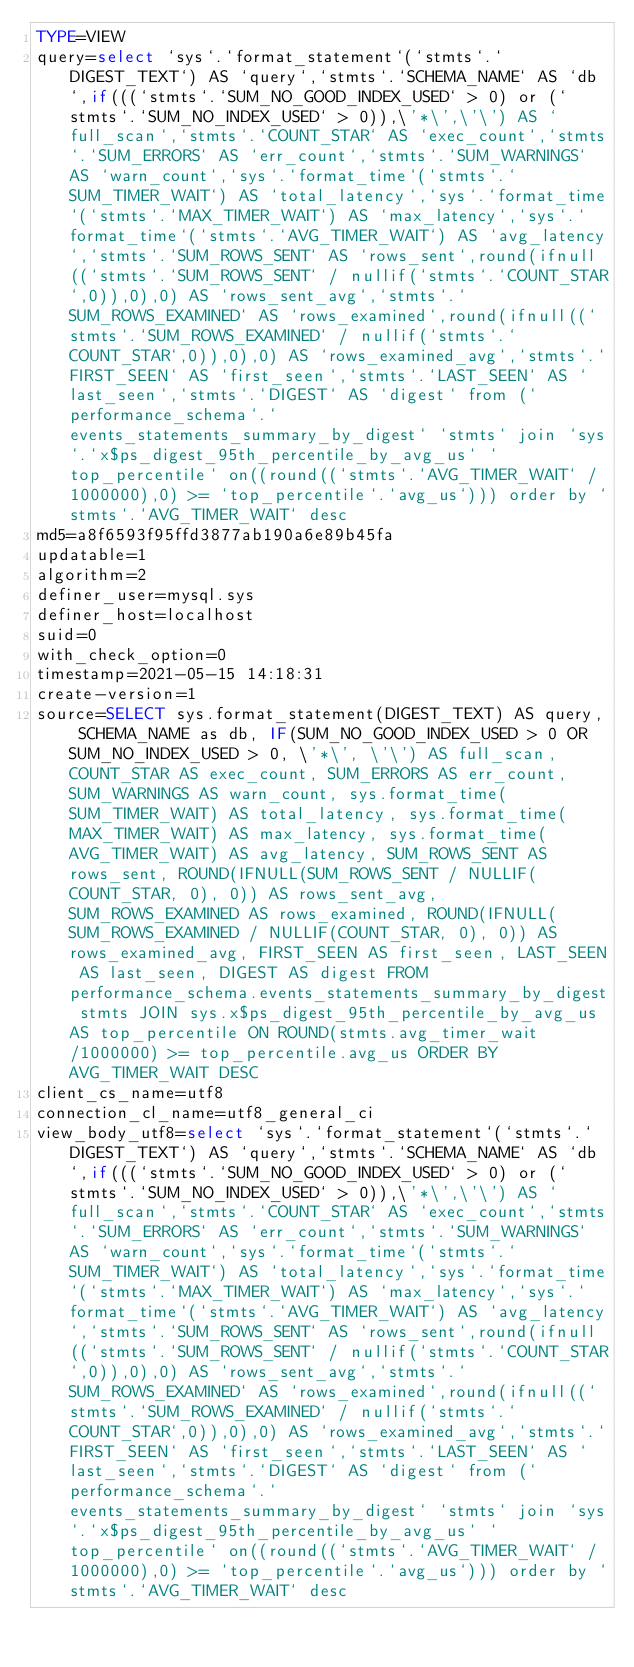<code> <loc_0><loc_0><loc_500><loc_500><_VisualBasic_>TYPE=VIEW
query=select `sys`.`format_statement`(`stmts`.`DIGEST_TEXT`) AS `query`,`stmts`.`SCHEMA_NAME` AS `db`,if(((`stmts`.`SUM_NO_GOOD_INDEX_USED` > 0) or (`stmts`.`SUM_NO_INDEX_USED` > 0)),\'*\',\'\') AS `full_scan`,`stmts`.`COUNT_STAR` AS `exec_count`,`stmts`.`SUM_ERRORS` AS `err_count`,`stmts`.`SUM_WARNINGS` AS `warn_count`,`sys`.`format_time`(`stmts`.`SUM_TIMER_WAIT`) AS `total_latency`,`sys`.`format_time`(`stmts`.`MAX_TIMER_WAIT`) AS `max_latency`,`sys`.`format_time`(`stmts`.`AVG_TIMER_WAIT`) AS `avg_latency`,`stmts`.`SUM_ROWS_SENT` AS `rows_sent`,round(ifnull((`stmts`.`SUM_ROWS_SENT` / nullif(`stmts`.`COUNT_STAR`,0)),0),0) AS `rows_sent_avg`,`stmts`.`SUM_ROWS_EXAMINED` AS `rows_examined`,round(ifnull((`stmts`.`SUM_ROWS_EXAMINED` / nullif(`stmts`.`COUNT_STAR`,0)),0),0) AS `rows_examined_avg`,`stmts`.`FIRST_SEEN` AS `first_seen`,`stmts`.`LAST_SEEN` AS `last_seen`,`stmts`.`DIGEST` AS `digest` from (`performance_schema`.`events_statements_summary_by_digest` `stmts` join `sys`.`x$ps_digest_95th_percentile_by_avg_us` `top_percentile` on((round((`stmts`.`AVG_TIMER_WAIT` / 1000000),0) >= `top_percentile`.`avg_us`))) order by `stmts`.`AVG_TIMER_WAIT` desc
md5=a8f6593f95ffd3877ab190a6e89b45fa
updatable=1
algorithm=2
definer_user=mysql.sys
definer_host=localhost
suid=0
with_check_option=0
timestamp=2021-05-15 14:18:31
create-version=1
source=SELECT sys.format_statement(DIGEST_TEXT) AS query, SCHEMA_NAME as db, IF(SUM_NO_GOOD_INDEX_USED > 0 OR SUM_NO_INDEX_USED > 0, \'*\', \'\') AS full_scan, COUNT_STAR AS exec_count, SUM_ERRORS AS err_count, SUM_WARNINGS AS warn_count, sys.format_time(SUM_TIMER_WAIT) AS total_latency, sys.format_time(MAX_TIMER_WAIT) AS max_latency, sys.format_time(AVG_TIMER_WAIT) AS avg_latency, SUM_ROWS_SENT AS rows_sent, ROUND(IFNULL(SUM_ROWS_SENT / NULLIF(COUNT_STAR, 0), 0)) AS rows_sent_avg, SUM_ROWS_EXAMINED AS rows_examined, ROUND(IFNULL(SUM_ROWS_EXAMINED / NULLIF(COUNT_STAR, 0), 0)) AS rows_examined_avg, FIRST_SEEN AS first_seen, LAST_SEEN AS last_seen, DIGEST AS digest FROM performance_schema.events_statements_summary_by_digest stmts JOIN sys.x$ps_digest_95th_percentile_by_avg_us AS top_percentile ON ROUND(stmts.avg_timer_wait/1000000) >= top_percentile.avg_us ORDER BY AVG_TIMER_WAIT DESC
client_cs_name=utf8
connection_cl_name=utf8_general_ci
view_body_utf8=select `sys`.`format_statement`(`stmts`.`DIGEST_TEXT`) AS `query`,`stmts`.`SCHEMA_NAME` AS `db`,if(((`stmts`.`SUM_NO_GOOD_INDEX_USED` > 0) or (`stmts`.`SUM_NO_INDEX_USED` > 0)),\'*\',\'\') AS `full_scan`,`stmts`.`COUNT_STAR` AS `exec_count`,`stmts`.`SUM_ERRORS` AS `err_count`,`stmts`.`SUM_WARNINGS` AS `warn_count`,`sys`.`format_time`(`stmts`.`SUM_TIMER_WAIT`) AS `total_latency`,`sys`.`format_time`(`stmts`.`MAX_TIMER_WAIT`) AS `max_latency`,`sys`.`format_time`(`stmts`.`AVG_TIMER_WAIT`) AS `avg_latency`,`stmts`.`SUM_ROWS_SENT` AS `rows_sent`,round(ifnull((`stmts`.`SUM_ROWS_SENT` / nullif(`stmts`.`COUNT_STAR`,0)),0),0) AS `rows_sent_avg`,`stmts`.`SUM_ROWS_EXAMINED` AS `rows_examined`,round(ifnull((`stmts`.`SUM_ROWS_EXAMINED` / nullif(`stmts`.`COUNT_STAR`,0)),0),0) AS `rows_examined_avg`,`stmts`.`FIRST_SEEN` AS `first_seen`,`stmts`.`LAST_SEEN` AS `last_seen`,`stmts`.`DIGEST` AS `digest` from (`performance_schema`.`events_statements_summary_by_digest` `stmts` join `sys`.`x$ps_digest_95th_percentile_by_avg_us` `top_percentile` on((round((`stmts`.`AVG_TIMER_WAIT` / 1000000),0) >= `top_percentile`.`avg_us`))) order by `stmts`.`AVG_TIMER_WAIT` desc
</code> 